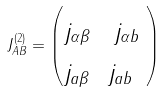Convert formula to latex. <formula><loc_0><loc_0><loc_500><loc_500>J _ { A B } ^ { ( 2 ) } = \begin{pmatrix} _ { j _ { \alpha \beta } } & _ { j _ { \alpha b } } \\ _ { j _ { a \beta } } & _ { j _ { a b } } \ \end{pmatrix}</formula> 